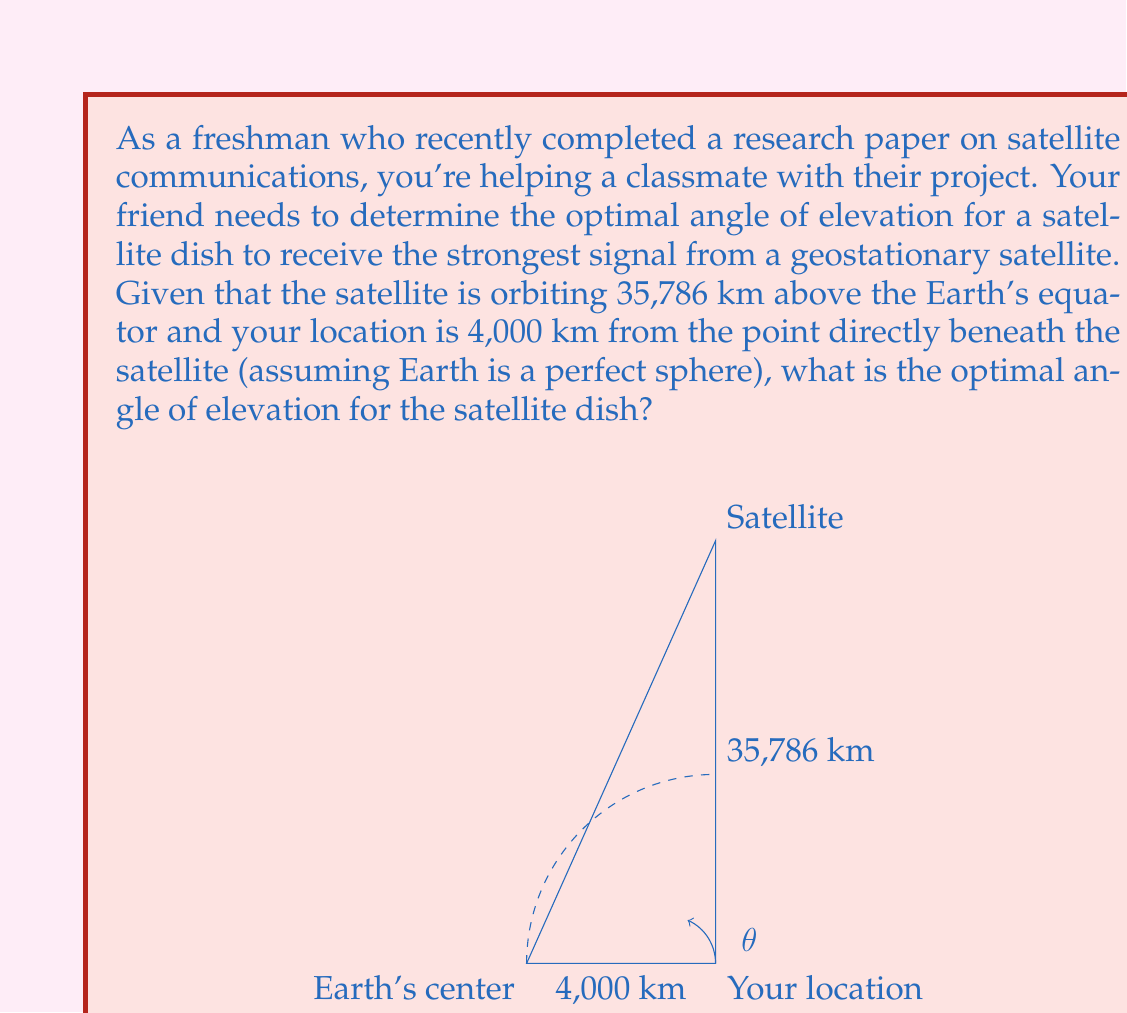Help me with this question. Let's approach this step-by-step:

1) First, we need to understand that the optimal angle of elevation is the angle between the horizontal plane at your location and the line of sight to the satellite.

2) We can treat this as a right-angled triangle problem, where:
   - The base of the triangle is the distance from your location to the point directly beneath the satellite (4,000 km)
   - The height of the triangle is the satellite's altitude (35,786 km)
   - The hypotenuse is the line of sight from your location to the satellite
   - The angle we're looking for is the angle between the base and the hypotenuse

3) We can use the arctangent function to find this angle. In a right-angled triangle:

   $$\tan(\theta) = \frac{\text{opposite}}{\text{adjacent}}$$

4) In our case:
   $$\tan(\theta) = \frac{35,786}{4,000}$$

5) To find $\theta$, we take the inverse tangent (arctangent) of both sides:

   $$\theta = \arctan(\frac{35,786}{4,000})$$

6) Using a calculator or computer:

   $$\theta \approx 83.6^\circ$$

7) This angle is measured from the horizontal. In satellite communications, the angle of elevation is typically measured from the vertical, so we need to subtract this from 90°:

   $$90^\circ - 83.6^\circ = 6.4^\circ$$

Therefore, the optimal angle of elevation for the satellite dish is approximately 83.6° from the horizontal, or 6.4° from the vertical.
Answer: $83.6^\circ$ from horizontal (or $6.4^\circ$ from vertical) 